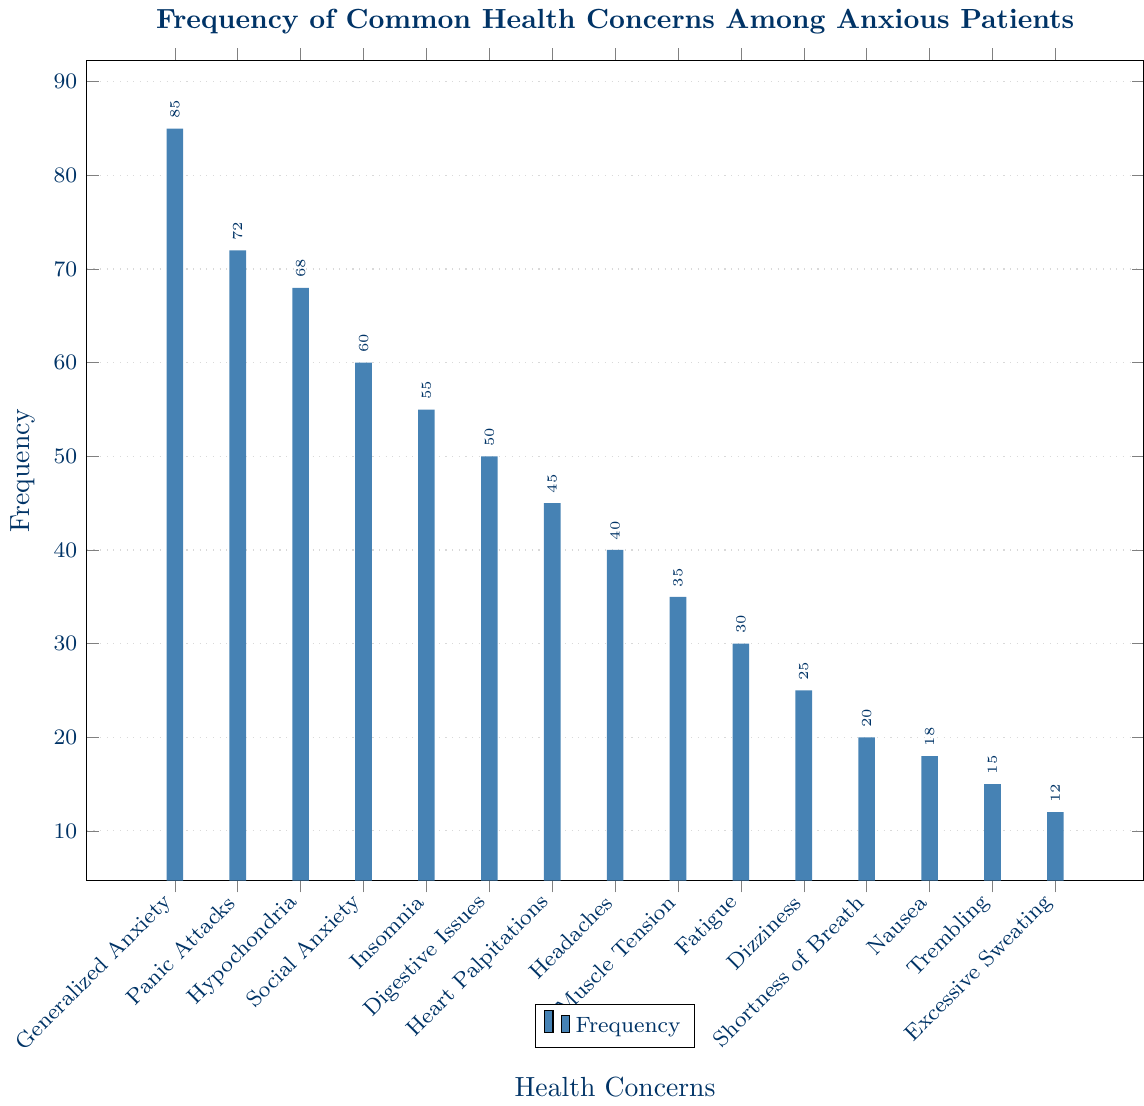How often do anxious patients report generalized anxiety compared to social anxiety? The bar chart shows that generalized anxiety is reported by 85 patients, while social anxiety is reported by 60 patients. Since 85 is greater than 60, generalized anxiety is more frequently reported.
Answer: Generalized anxiety is more frequent Which health concern is reported the least among anxious patients? From the bar chart, the shortest bar indicates "Excessive Sweating," which has a frequency of 12. Hence, excessive sweating is reported the least.
Answer: Excessive Sweating Are heart palpitations reported more frequently than muscle tension? By comparing the heights of the bars, we see that heart palpitations have a frequency of 45, while muscle tension has a frequency of 35. Thus, heart palpitations are reported more frequently than muscle tension.
Answer: Yes, heart palpitations are more frequent What is the total reported frequency of headaches and dizziness combined? The bar chart shows that headaches have a frequency of 40, and dizziness has a frequency of 25. Therefore, the combined total is 40 + 25 = 65.
Answer: 65 How many more patients report trembling compared to excessive sweating? Trembling has a frequency of 15, whereas excessive sweating is reported by 12 patients. Therefore, 15 - 12 = 3 more patients report trembling.
Answer: 3 more patients Which health concern has the highest positive outcome percentage, and what is that percentage? Although the bar chart primarily shows frequency, it also indicates some percentages where visually applicable. The highest positive outcome percentage indicated is for shortness of breath at 97%.
Answer: Shortness of breath, 97% How does the reporting frequency of hypochondria compare to that of insomnia? The bar for hypochondria has a frequency of 68, while insomnia has a frequency of 55. Comparatively, hypochondria is reported more frequently.
Answer: Hypochondria is more frequent Among the listed health concerns, which have frequencies between 50 and 70 inclusive? From the chart: Hypochondria (68), Social Anxiety (60), and Digestive Issues (50) are within this range.
Answer: Hypochondria, Social Anxiety, Digestive Issues What is the average frequency of the top three most commonly reported health concerns? The top three concerns are Generalized Anxiety (85), Panic Attacks (72), and Hypochondria (68). The average is (85 + 72 + 68) / 3 = 225 / 3 = 75.
Answer: 75 Which health concerns have a higher reporting frequency: those in the top third or the bottom third in frequency? The top third frequencies: Generalized Anxiety (85), Panic Attacks (72), Hypochondria (68), Social Anxiety (60), and Insomnia (55). The bottom third frequencies: Fatigue (30), Dizziness (25), Shortness of Breath (20), Nausea (18), Trembling (15), Excessive Sweating (12). Total top third frequencies: 340. Total bottom third frequencies: 120. The top third is higher.
Answer: Top third 